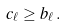<formula> <loc_0><loc_0><loc_500><loc_500>c _ { \ell } \geq b _ { \ell } \, .</formula> 